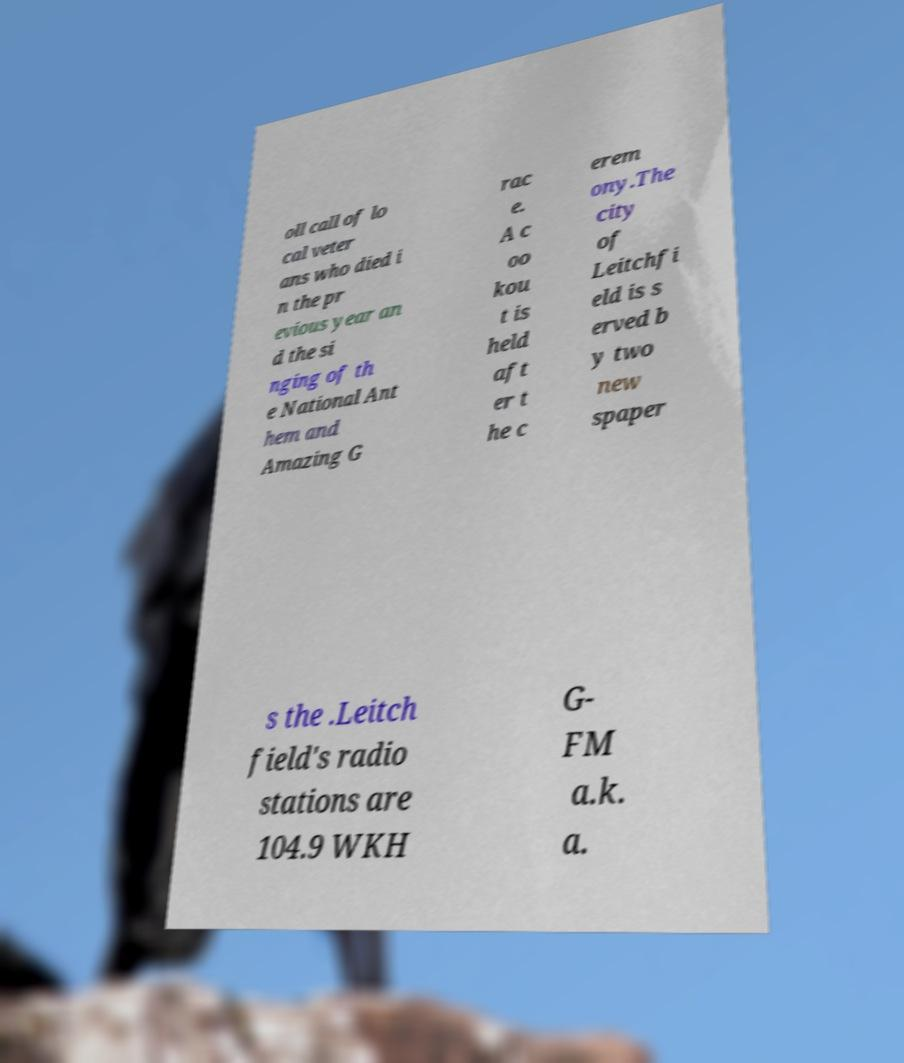Can you accurately transcribe the text from the provided image for me? oll call of lo cal veter ans who died i n the pr evious year an d the si nging of th e National Ant hem and Amazing G rac e. A c oo kou t is held aft er t he c erem ony.The city of Leitchfi eld is s erved b y two new spaper s the .Leitch field's radio stations are 104.9 WKH G- FM a.k. a. 